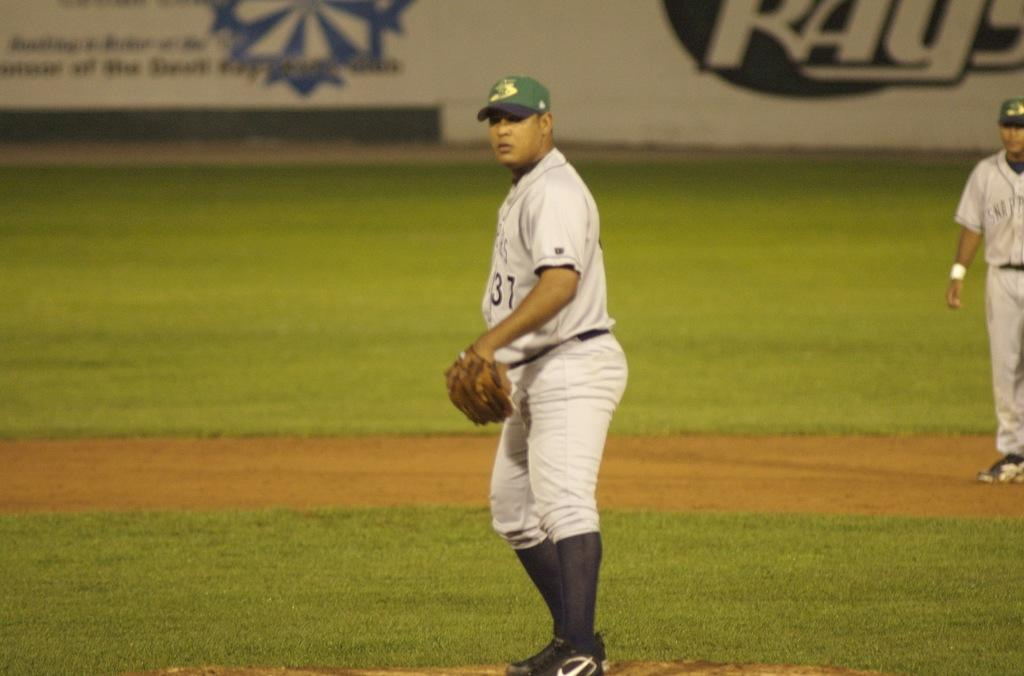<image>
Relay a brief, clear account of the picture shown. A baseball pitcher with uniform number 37 is deciding on a pitch. 